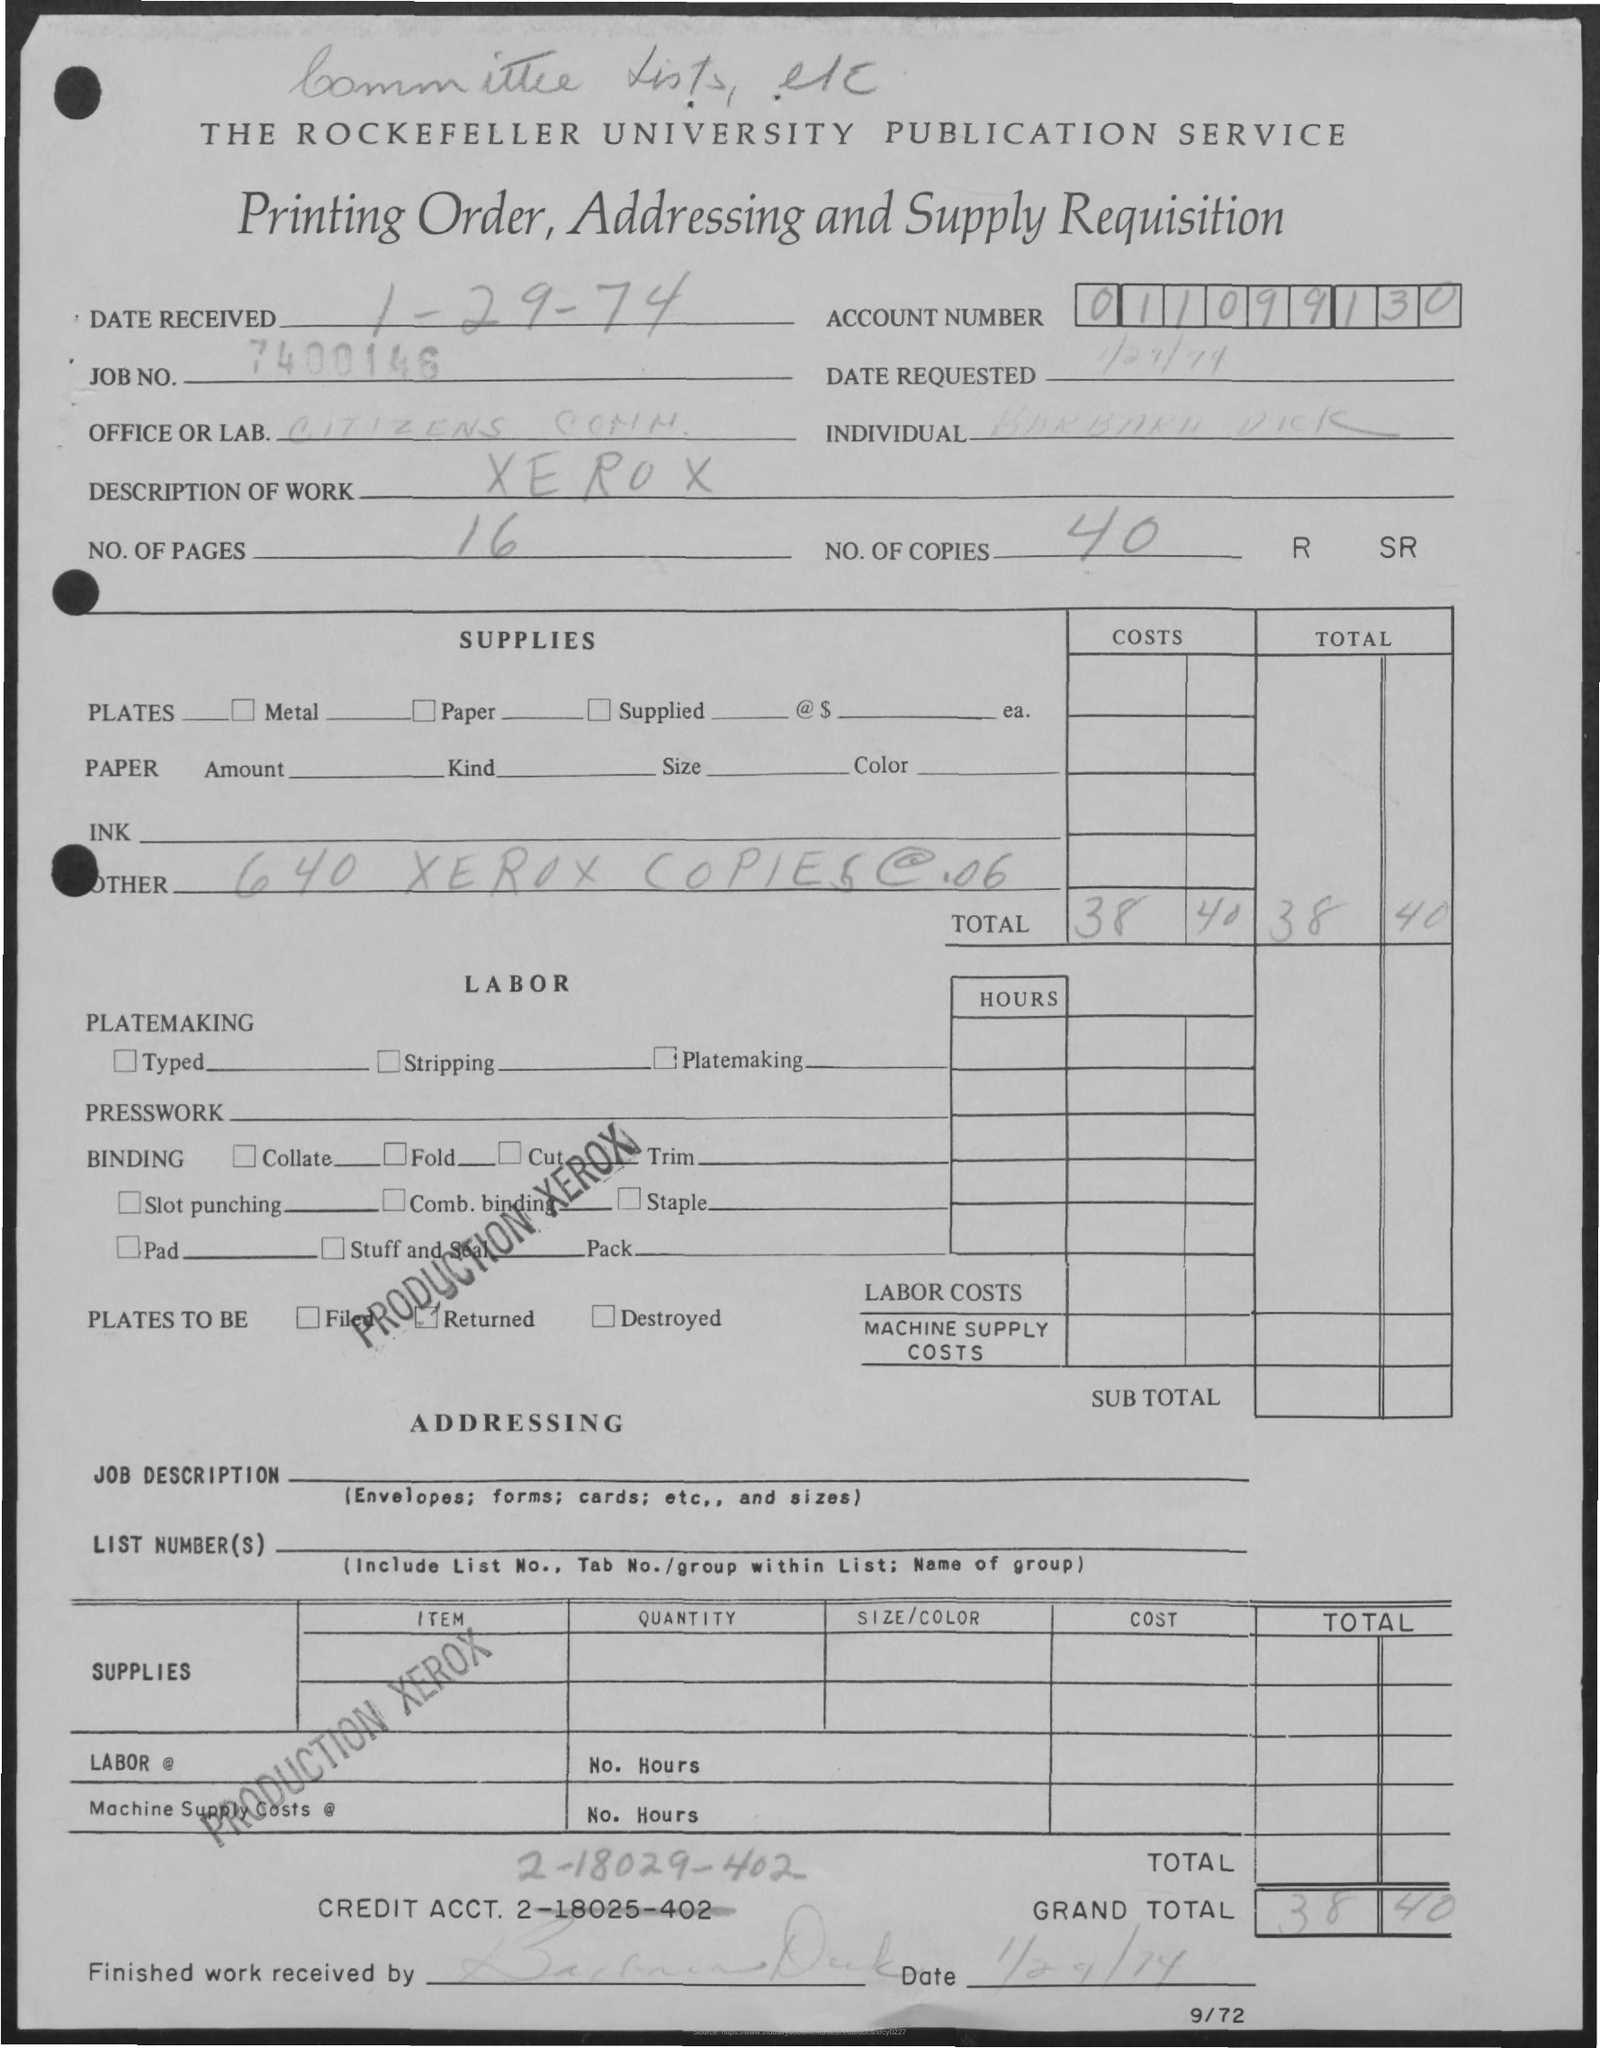Give some essential details in this illustration. There are 40 copies. The description of work required for a Xerox is... The grand total is 38.40 dollars. There are 16 pages in total. On January 29, 1974, the date received was. 